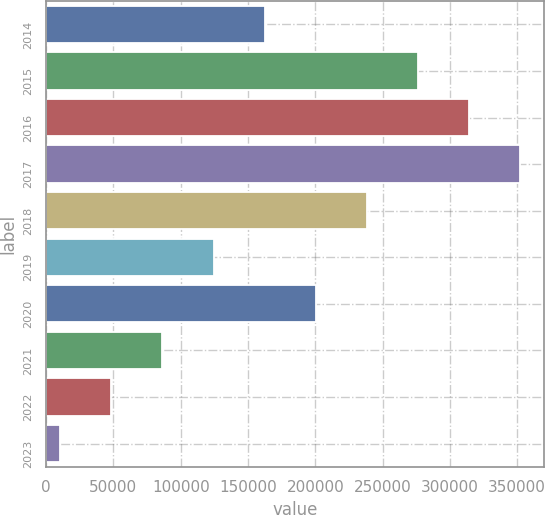Convert chart to OTSL. <chart><loc_0><loc_0><loc_500><loc_500><bar_chart><fcel>2014<fcel>2015<fcel>2016<fcel>2017<fcel>2018<fcel>2019<fcel>2020<fcel>2021<fcel>2022<fcel>2023<nl><fcel>162446<fcel>276433<fcel>314429<fcel>352425<fcel>238437<fcel>124450<fcel>200442<fcel>86453.8<fcel>48457.9<fcel>10462<nl></chart> 